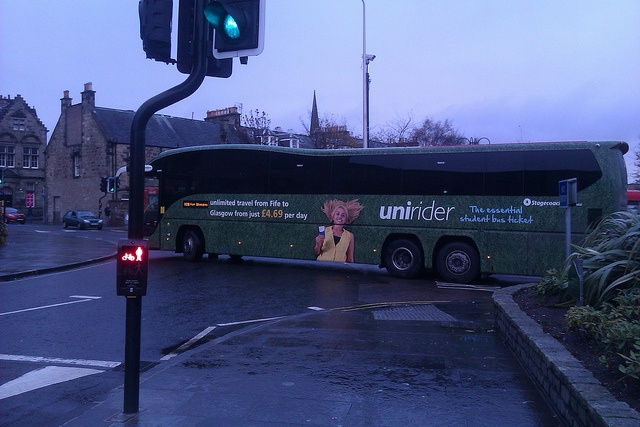Describe the objects in this image and their specific colors. I can see bus in lightblue, black, navy, darkblue, and gray tones, traffic light in lightblue, navy, and gray tones, traffic light in lightblue, navy, darkblue, and blue tones, traffic light in lightblue, black, maroon, purple, and navy tones, and car in lightblue, navy, black, and blue tones in this image. 